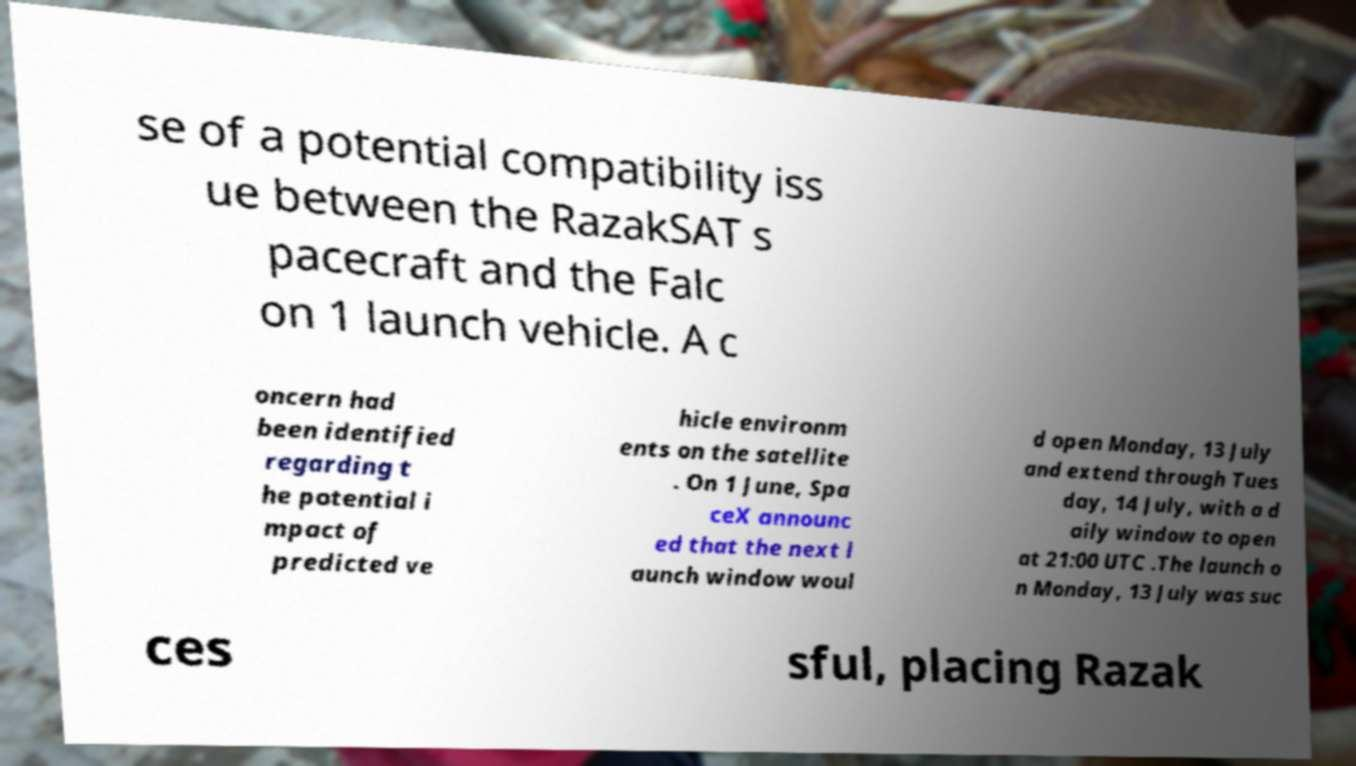What messages or text are displayed in this image? I need them in a readable, typed format. se of a potential compatibility iss ue between the RazakSAT s pacecraft and the Falc on 1 launch vehicle. A c oncern had been identified regarding t he potential i mpact of predicted ve hicle environm ents on the satellite . On 1 June, Spa ceX announc ed that the next l aunch window woul d open Monday, 13 July and extend through Tues day, 14 July, with a d aily window to open at 21:00 UTC .The launch o n Monday, 13 July was suc ces sful, placing Razak 